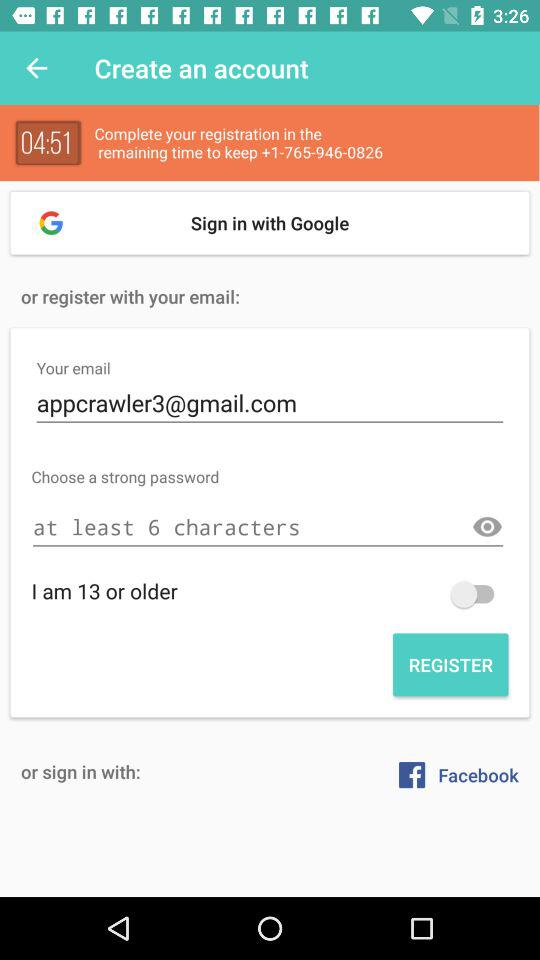What is the minimum number of characters required for a password? The minimum number of characters required for a password is 6. 